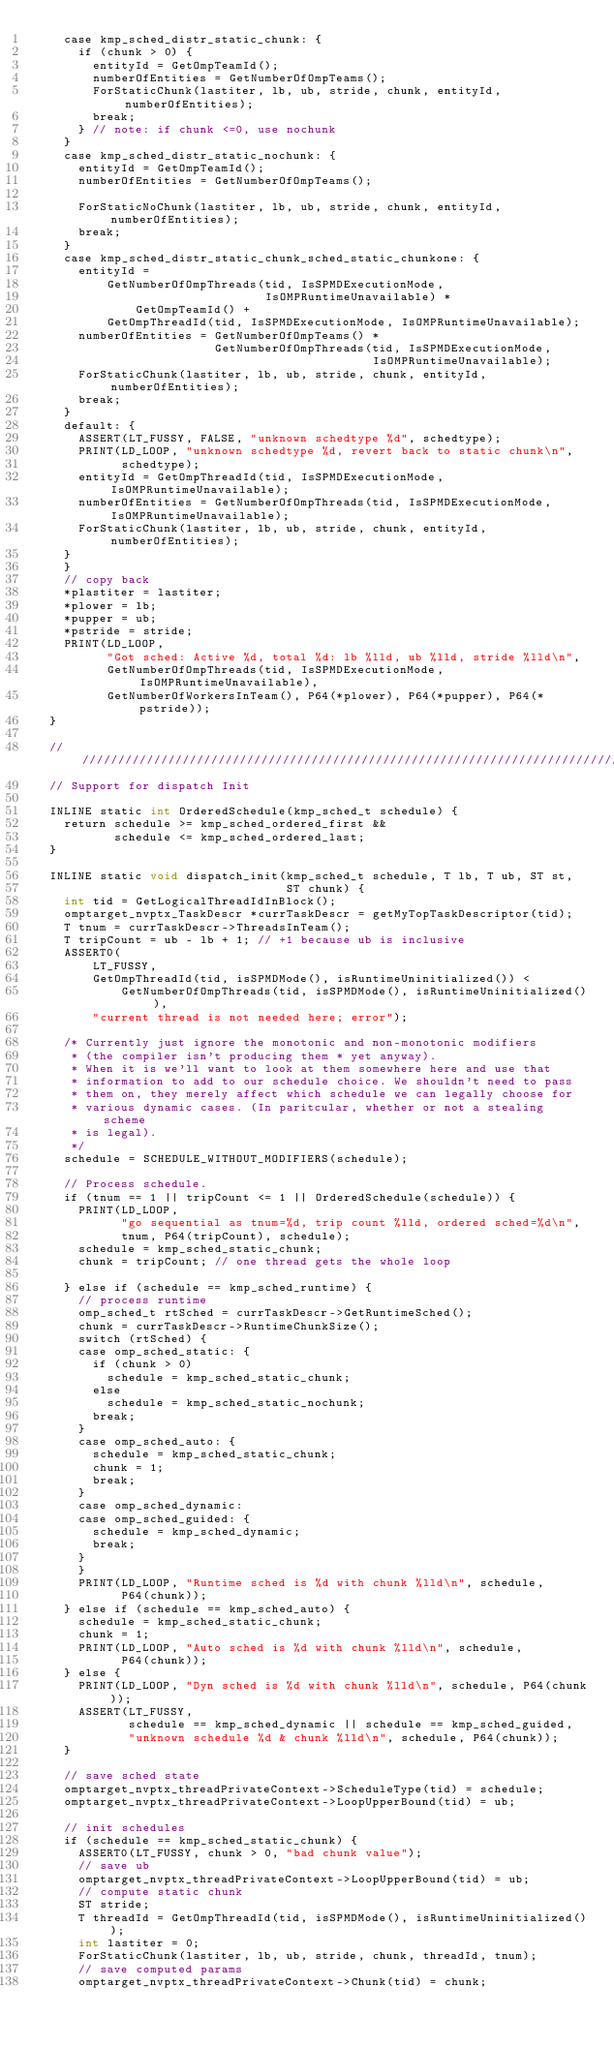<code> <loc_0><loc_0><loc_500><loc_500><_Cuda_>    case kmp_sched_distr_static_chunk: {
      if (chunk > 0) {
        entityId = GetOmpTeamId();
        numberOfEntities = GetNumberOfOmpTeams();
        ForStaticChunk(lastiter, lb, ub, stride, chunk, entityId, numberOfEntities);
        break;
      } // note: if chunk <=0, use nochunk
    }
    case kmp_sched_distr_static_nochunk: {
      entityId = GetOmpTeamId();
      numberOfEntities = GetNumberOfOmpTeams();

      ForStaticNoChunk(lastiter, lb, ub, stride, chunk, entityId, numberOfEntities);
      break;
    }
    case kmp_sched_distr_static_chunk_sched_static_chunkone: {
      entityId =
          GetNumberOfOmpThreads(tid, IsSPMDExecutionMode,
                                IsOMPRuntimeUnavailable) *
              GetOmpTeamId() +
          GetOmpThreadId(tid, IsSPMDExecutionMode, IsOMPRuntimeUnavailable);
      numberOfEntities = GetNumberOfOmpTeams() *
                         GetNumberOfOmpThreads(tid, IsSPMDExecutionMode,
                                               IsOMPRuntimeUnavailable);
      ForStaticChunk(lastiter, lb, ub, stride, chunk, entityId, numberOfEntities);
      break;
    }
    default: {
      ASSERT(LT_FUSSY, FALSE, "unknown schedtype %d", schedtype);
      PRINT(LD_LOOP, "unknown schedtype %d, revert back to static chunk\n",
            schedtype);
      entityId = GetOmpThreadId(tid, IsSPMDExecutionMode, IsOMPRuntimeUnavailable);
      numberOfEntities = GetNumberOfOmpThreads(tid, IsSPMDExecutionMode, IsOMPRuntimeUnavailable);
      ForStaticChunk(lastiter, lb, ub, stride, chunk, entityId, numberOfEntities);
    }
    }
    // copy back
    *plastiter = lastiter;
    *plower = lb;
    *pupper = ub;
    *pstride = stride;
    PRINT(LD_LOOP,
          "Got sched: Active %d, total %d: lb %lld, ub %lld, stride %lld\n",
          GetNumberOfOmpThreads(tid, IsSPMDExecutionMode, IsOMPRuntimeUnavailable),
          GetNumberOfWorkersInTeam(), P64(*plower), P64(*pupper), P64(*pstride));
  }

  ////////////////////////////////////////////////////////////////////////////////
  // Support for dispatch Init

  INLINE static int OrderedSchedule(kmp_sched_t schedule) {
    return schedule >= kmp_sched_ordered_first &&
           schedule <= kmp_sched_ordered_last;
  }

  INLINE static void dispatch_init(kmp_sched_t schedule, T lb, T ub, ST st,
                                   ST chunk) {
    int tid = GetLogicalThreadIdInBlock();
    omptarget_nvptx_TaskDescr *currTaskDescr = getMyTopTaskDescriptor(tid);
    T tnum = currTaskDescr->ThreadsInTeam();
    T tripCount = ub - lb + 1; // +1 because ub is inclusive
    ASSERT0(
        LT_FUSSY,
        GetOmpThreadId(tid, isSPMDMode(), isRuntimeUninitialized()) <
            GetNumberOfOmpThreads(tid, isSPMDMode(), isRuntimeUninitialized()),
        "current thread is not needed here; error");

    /* Currently just ignore the monotonic and non-monotonic modifiers
     * (the compiler isn't producing them * yet anyway).
     * When it is we'll want to look at them somewhere here and use that
     * information to add to our schedule choice. We shouldn't need to pass
     * them on, they merely affect which schedule we can legally choose for
     * various dynamic cases. (In paritcular, whether or not a stealing scheme
     * is legal).
     */
    schedule = SCHEDULE_WITHOUT_MODIFIERS(schedule);

    // Process schedule.
    if (tnum == 1 || tripCount <= 1 || OrderedSchedule(schedule)) {
      PRINT(LD_LOOP,
            "go sequential as tnum=%d, trip count %lld, ordered sched=%d\n",
            tnum, P64(tripCount), schedule);
      schedule = kmp_sched_static_chunk;
      chunk = tripCount; // one thread gets the whole loop

    } else if (schedule == kmp_sched_runtime) {
      // process runtime
      omp_sched_t rtSched = currTaskDescr->GetRuntimeSched();
      chunk = currTaskDescr->RuntimeChunkSize();
      switch (rtSched) {
      case omp_sched_static: {
        if (chunk > 0)
          schedule = kmp_sched_static_chunk;
        else
          schedule = kmp_sched_static_nochunk;
        break;
      }
      case omp_sched_auto: {
        schedule = kmp_sched_static_chunk;
        chunk = 1;
        break;
      }
      case omp_sched_dynamic:
      case omp_sched_guided: {
        schedule = kmp_sched_dynamic;
        break;
      }
      }
      PRINT(LD_LOOP, "Runtime sched is %d with chunk %lld\n", schedule,
            P64(chunk));
    } else if (schedule == kmp_sched_auto) {
      schedule = kmp_sched_static_chunk;
      chunk = 1;
      PRINT(LD_LOOP, "Auto sched is %d with chunk %lld\n", schedule,
            P64(chunk));
    } else {
      PRINT(LD_LOOP, "Dyn sched is %d with chunk %lld\n", schedule, P64(chunk));
      ASSERT(LT_FUSSY,
             schedule == kmp_sched_dynamic || schedule == kmp_sched_guided,
             "unknown schedule %d & chunk %lld\n", schedule, P64(chunk));
    }

    // save sched state
    omptarget_nvptx_threadPrivateContext->ScheduleType(tid) = schedule;
    omptarget_nvptx_threadPrivateContext->LoopUpperBound(tid) = ub;

    // init schedules
    if (schedule == kmp_sched_static_chunk) {
      ASSERT0(LT_FUSSY, chunk > 0, "bad chunk value");
      // save ub
      omptarget_nvptx_threadPrivateContext->LoopUpperBound(tid) = ub;
      // compute static chunk
      ST stride;
      T threadId = GetOmpThreadId(tid, isSPMDMode(), isRuntimeUninitialized());
      int lastiter = 0;
      ForStaticChunk(lastiter, lb, ub, stride, chunk, threadId, tnum);
      // save computed params
      omptarget_nvptx_threadPrivateContext->Chunk(tid) = chunk;</code> 